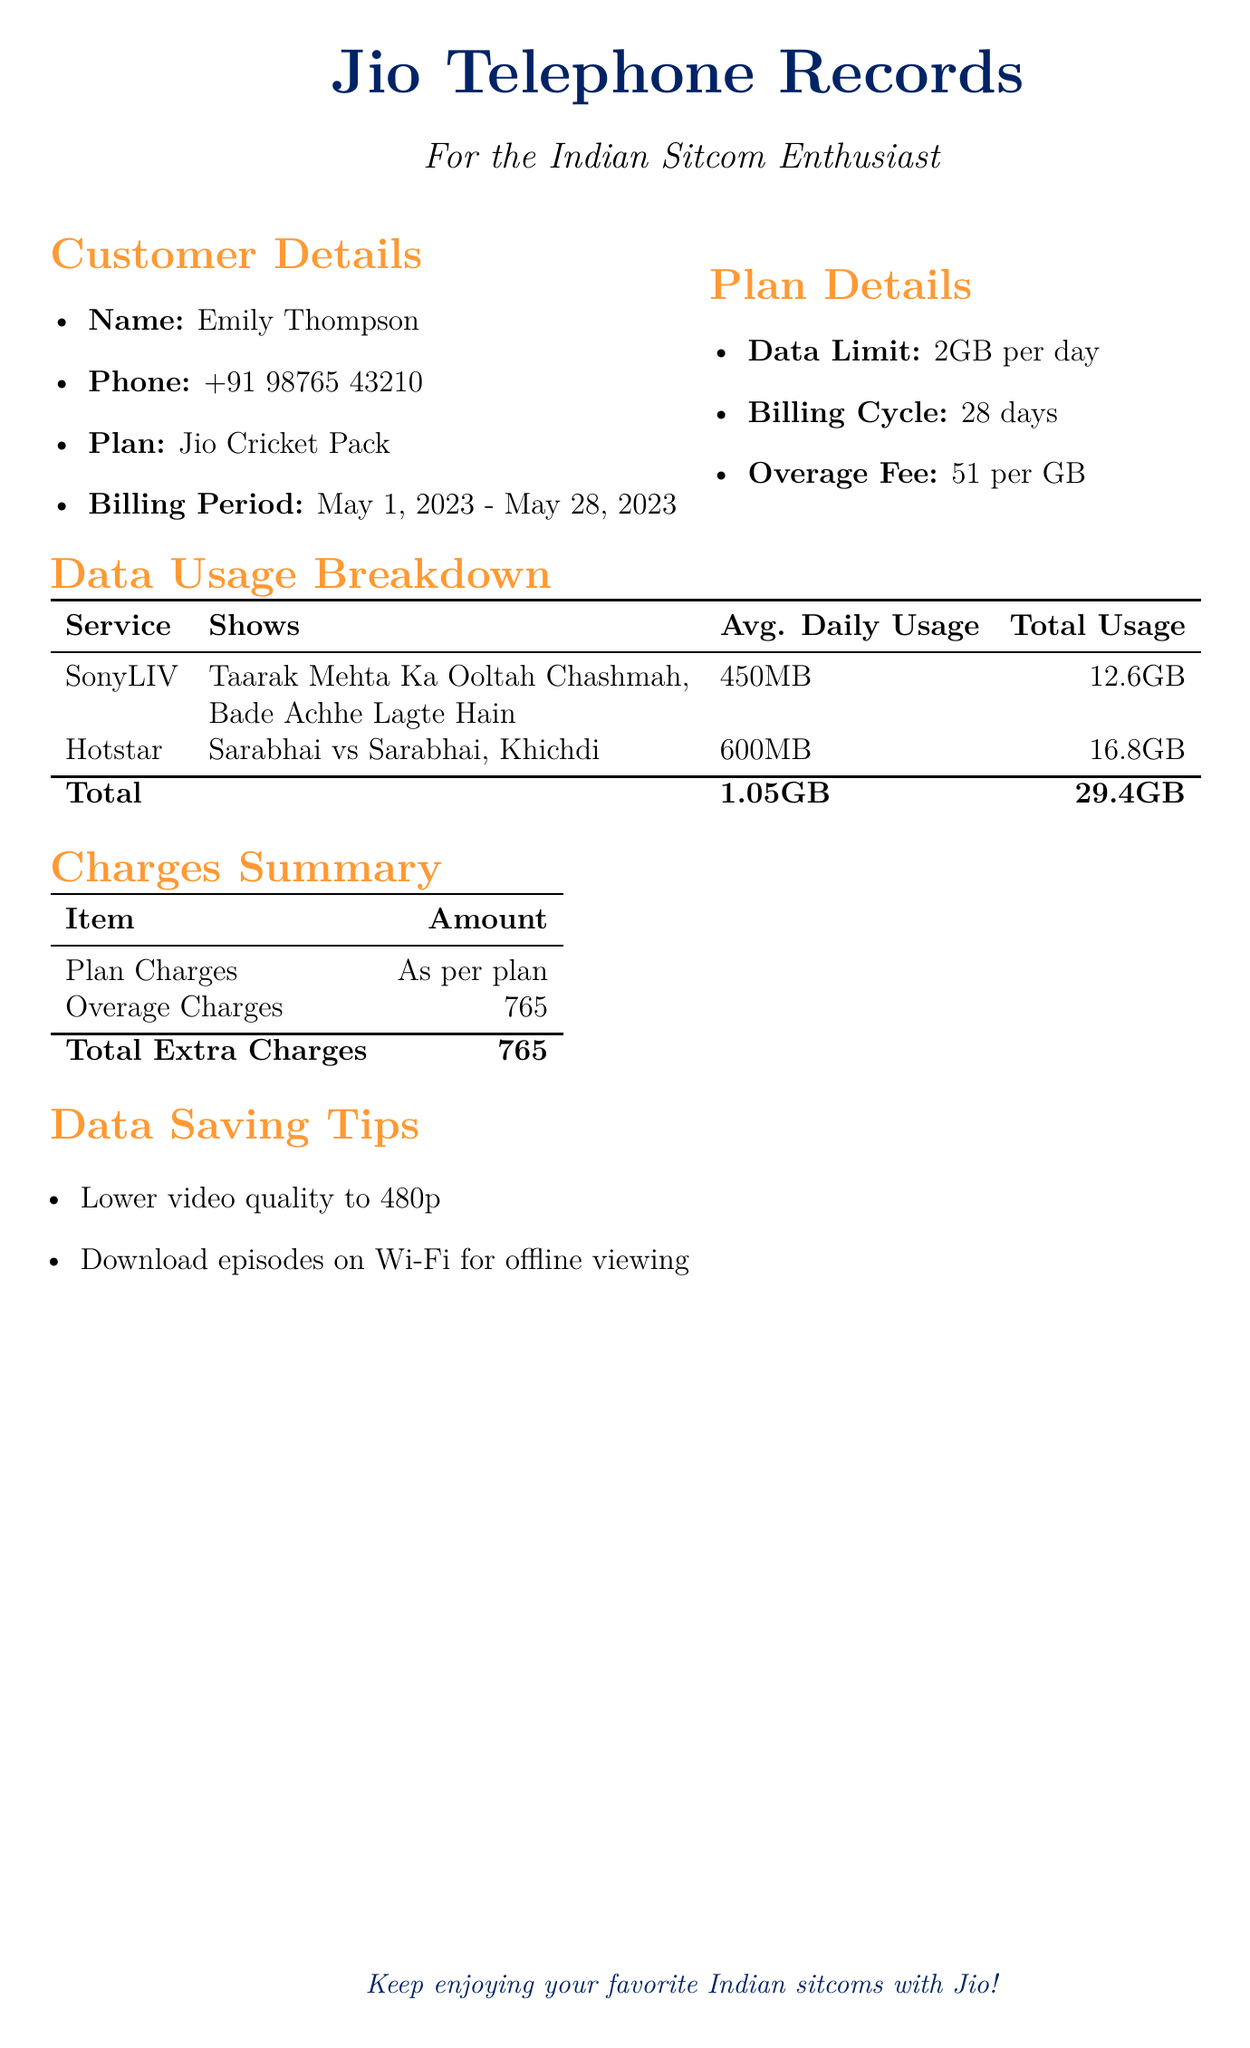What is the name of the customer? The name of the customer is clearly mentioned in the document under "Customer Details."
Answer: Emily Thompson What is the data limit per day? The document specifies the data limit amount under "Plan Details."
Answer: 2GB per day What is the total usage of data? The total usage can be found in the "Data Usage Breakdown" section, summarizing all data used during the billing period.
Answer: 29.4GB How much are the overage charges? The overage charges are stated in the "Charges Summary" section of the document.
Answer: ₹765 What is the average daily usage for SonyLIV? The document lists the average daily usage specifically for SonyLIV in the "Data Usage Breakdown."
Answer: 450MB What shows were streamed on Hotstar? The shows streamed on Hotstar are recorded under the "Data Usage Breakdown" section.
Answer: Sarabhai vs Sarabhai, Khichdi What is the billing period for the customer's plan? The billing period is detailed in the "Customer Details" section of the document.
Answer: May 1, 2023 - May 28, 2023 What is one data-saving tip provided in the document? The document offers data-saving tips at the end, recommending a practical approach for managing data usage.
Answer: Lower video quality to 480p What is the plan type for the customer? The plan type can be found under "Customer Details" where the customer's plan information is provided.
Answer: Jio Cricket Pack 